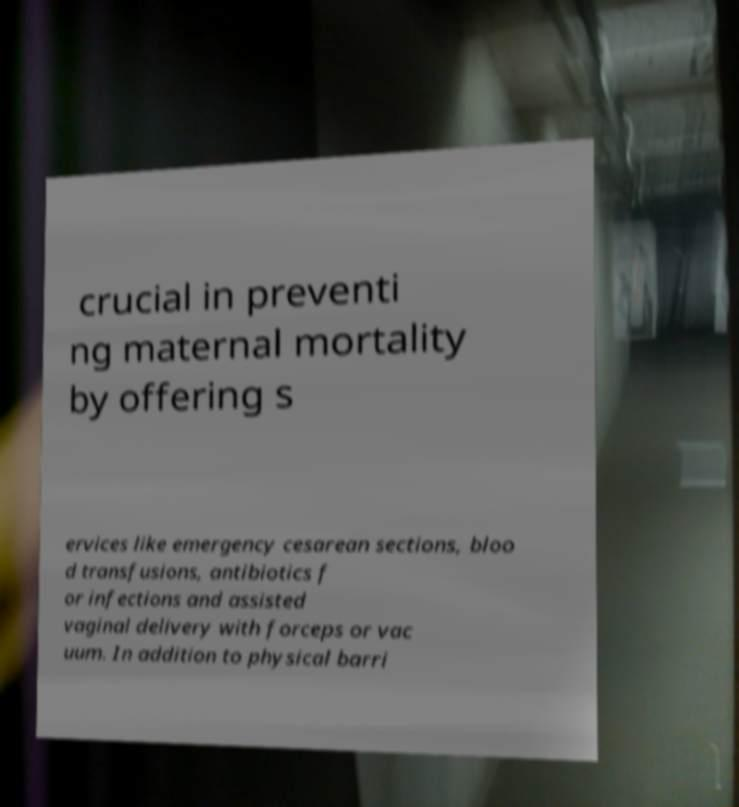What messages or text are displayed in this image? I need them in a readable, typed format. crucial in preventi ng maternal mortality by offering s ervices like emergency cesarean sections, bloo d transfusions, antibiotics f or infections and assisted vaginal delivery with forceps or vac uum. In addition to physical barri 